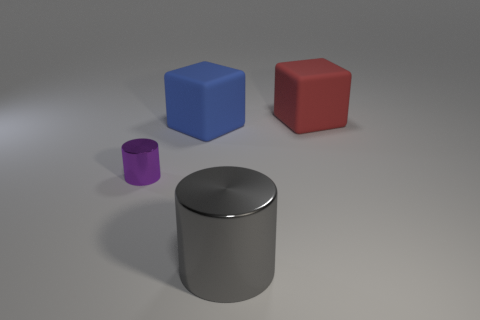Add 1 big rubber things. How many objects exist? 5 Subtract 0 brown cylinders. How many objects are left? 4 Subtract all red rubber cylinders. Subtract all blue blocks. How many objects are left? 3 Add 2 small purple metallic cylinders. How many small purple metallic cylinders are left? 3 Add 3 tiny purple metallic cylinders. How many tiny purple metallic cylinders exist? 4 